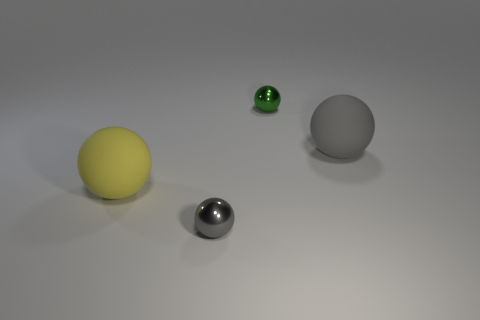There is a large object that is right of the tiny shiny sphere that is in front of the large matte ball left of the large gray thing; what is its material?
Offer a terse response. Rubber. How many objects are large things or large cyan cylinders?
Your answer should be compact. 2. There is a metal sphere left of the small green sphere; is its color the same as the large rubber object that is to the right of the tiny green shiny sphere?
Provide a succinct answer. Yes. There is a matte object that is the same size as the gray matte ball; what shape is it?
Your answer should be compact. Sphere. What number of things are balls that are behind the tiny gray metal thing or gray balls in front of the big gray matte sphere?
Offer a terse response. 4. Is the number of tiny objects less than the number of green metallic balls?
Your response must be concise. No. What material is the yellow ball that is the same size as the gray matte sphere?
Your answer should be very brief. Rubber. Does the gray object to the right of the gray metallic sphere have the same size as the shiny object that is on the right side of the tiny gray thing?
Your answer should be compact. No. Are there any green spheres that have the same material as the small gray ball?
Your response must be concise. Yes. What number of objects are large spheres that are on the left side of the green thing or big red things?
Offer a terse response. 1. 